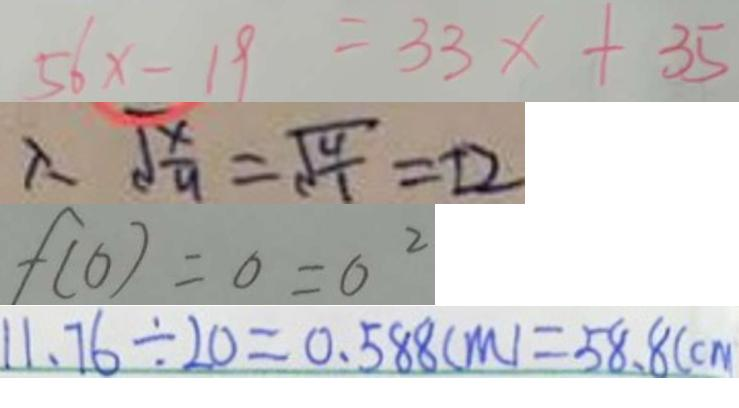<formula> <loc_0><loc_0><loc_500><loc_500>5 6 x - 1 9 = 3 3 x + 3 5 
 \therefore \sqrt { \frac { x } { 9 } } = \sqrt { \frac { 4 } { 1 } } = \pm 2 
 f ( 0 ) = 0 = 0 ^ { 2 } 
 1 1 . 7 6 \div 2 0 = 0 . 5 8 8 ( m ) = 5 8 . 8 ( c m</formula> 